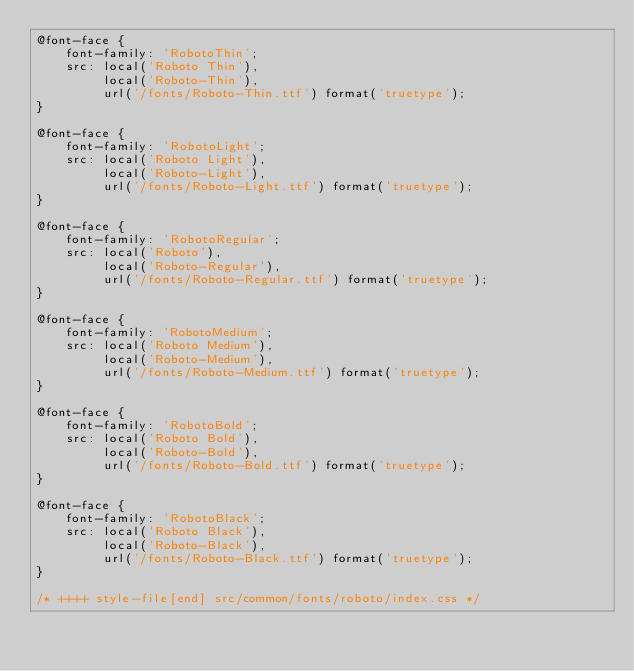<code> <loc_0><loc_0><loc_500><loc_500><_CSS_>@font-face {
    font-family: 'RobotoThin';
    src: local('Roboto Thin'),
         local('Roboto-Thin'),
         url('/fonts/Roboto-Thin.ttf') format('truetype');
}

@font-face {
    font-family: 'RobotoLight';
    src: local('Roboto Light'),
         local('Roboto-Light'),
         url('/fonts/Roboto-Light.ttf') format('truetype');
}

@font-face {
    font-family: 'RobotoRegular';
    src: local('Roboto'),
         local('Roboto-Regular'),
         url('/fonts/Roboto-Regular.ttf') format('truetype');
}

@font-face {
    font-family: 'RobotoMedium';
    src: local('Roboto Medium'),
         local('Roboto-Medium'),
         url('/fonts/Roboto-Medium.ttf') format('truetype');
}

@font-face {
    font-family: 'RobotoBold';
    src: local('Roboto Bold'),
         local('Roboto-Bold'),
         url('/fonts/Roboto-Bold.ttf') format('truetype');
}

@font-face {
    font-family: 'RobotoBlack';
    src: local('Roboto Black'),
         local('Roboto-Black'),
         url('/fonts/Roboto-Black.ttf') format('truetype');
}

/* ++++ style-file[end] src/common/fonts/roboto/index.css */
</code> 